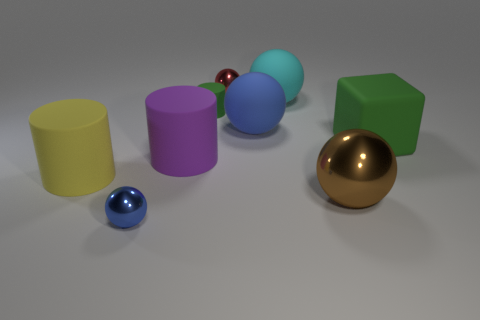Subtract all small shiny balls. How many balls are left? 3 Subtract all cyan balls. How many balls are left? 4 Subtract 1 balls. How many balls are left? 4 Subtract all purple balls. Subtract all yellow cubes. How many balls are left? 5 Subtract all spheres. How many objects are left? 4 Add 2 tiny blue objects. How many tiny blue objects are left? 3 Add 1 small blue things. How many small blue things exist? 2 Subtract 0 red cylinders. How many objects are left? 9 Subtract all large green things. Subtract all tiny purple things. How many objects are left? 8 